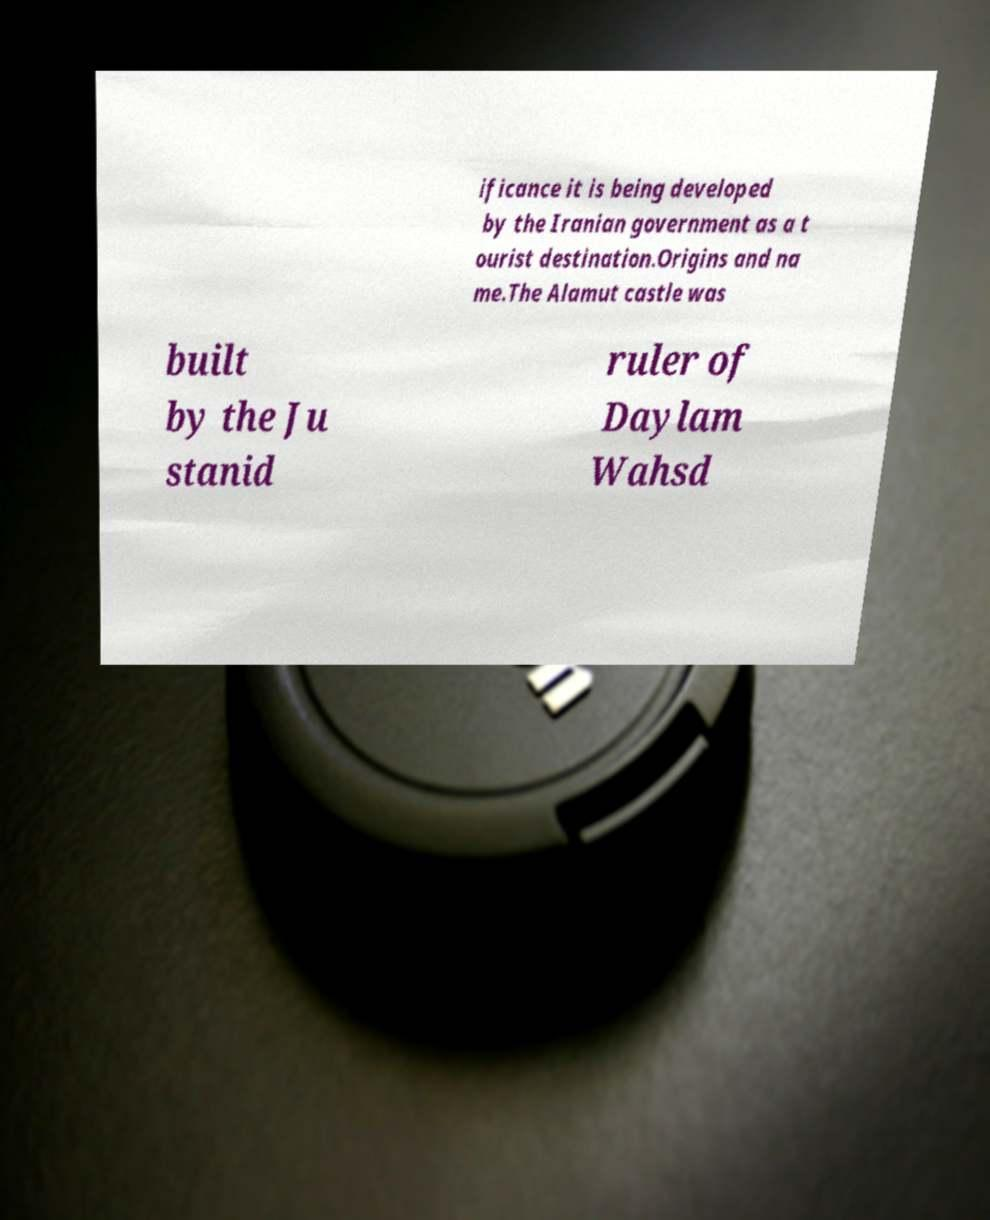Please read and relay the text visible in this image. What does it say? ificance it is being developed by the Iranian government as a t ourist destination.Origins and na me.The Alamut castle was built by the Ju stanid ruler of Daylam Wahsd 